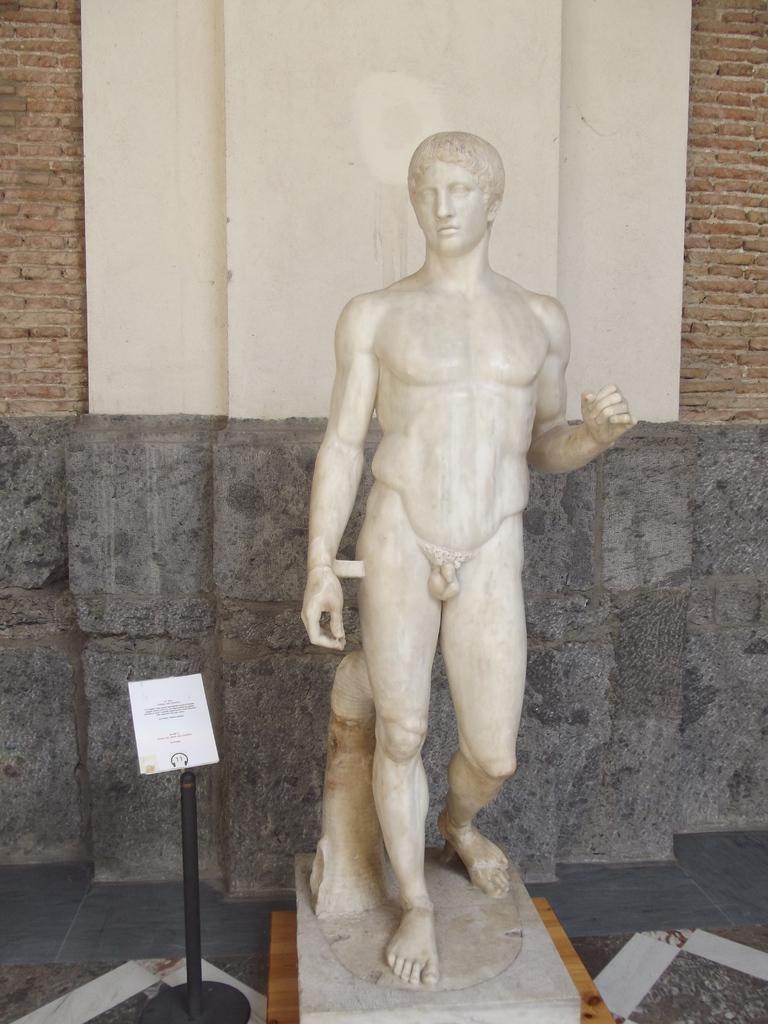Please provide a concise description of this image. In the middle of this image, there is a statue of a nude person. Besides this statue, there is a small pole on a platform. Beside this pole, there is a board attached to a pole. In the background, there is a brick wall connected to a pillar. 